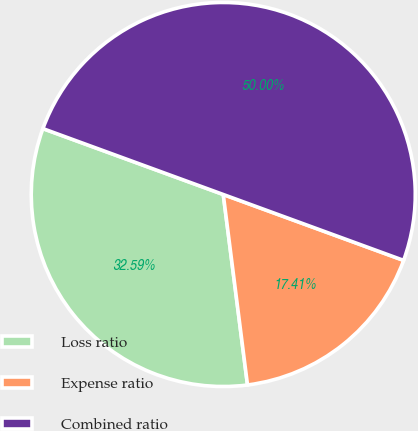Convert chart to OTSL. <chart><loc_0><loc_0><loc_500><loc_500><pie_chart><fcel>Loss ratio<fcel>Expense ratio<fcel>Combined ratio<nl><fcel>32.59%<fcel>17.41%<fcel>50.0%<nl></chart> 